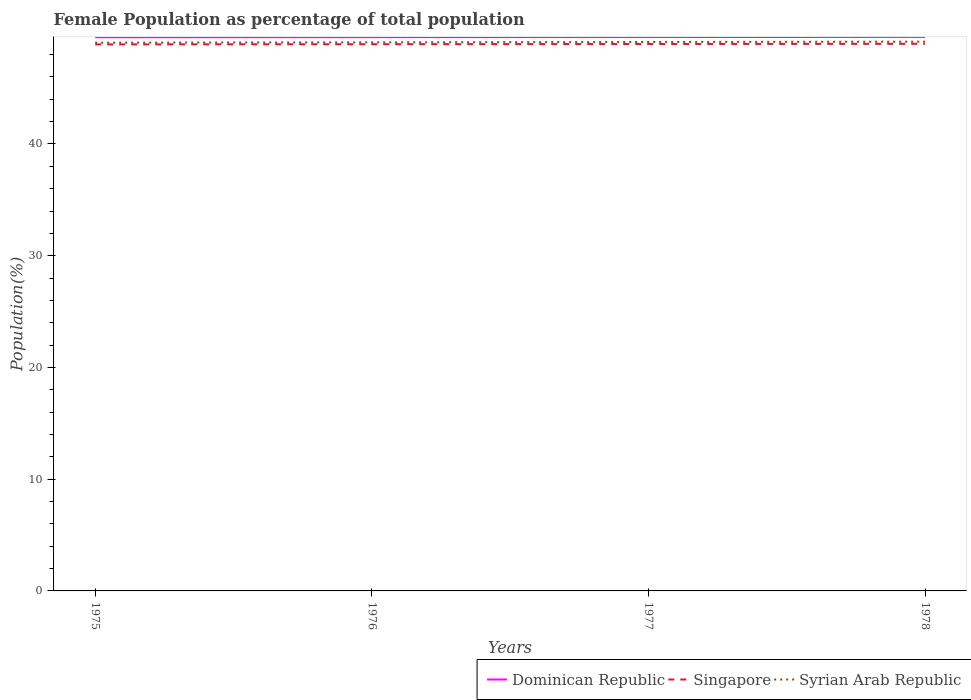Across all years, what is the maximum female population in in Singapore?
Provide a short and direct response. 48.91. In which year was the female population in in Syrian Arab Republic maximum?
Give a very brief answer. 1975. What is the total female population in in Syrian Arab Republic in the graph?
Provide a short and direct response. -0.03. What is the difference between the highest and the second highest female population in in Singapore?
Provide a succinct answer. 0.05. Is the female population in in Dominican Republic strictly greater than the female population in in Singapore over the years?
Make the answer very short. No. How many lines are there?
Your answer should be compact. 3. How many years are there in the graph?
Offer a terse response. 4. Are the values on the major ticks of Y-axis written in scientific E-notation?
Your answer should be very brief. No. What is the title of the graph?
Your answer should be compact. Female Population as percentage of total population. What is the label or title of the Y-axis?
Your answer should be compact. Population(%). What is the Population(%) in Dominican Republic in 1975?
Provide a succinct answer. 49.55. What is the Population(%) in Singapore in 1975?
Offer a very short reply. 48.91. What is the Population(%) in Syrian Arab Republic in 1975?
Offer a very short reply. 49.07. What is the Population(%) in Dominican Republic in 1976?
Ensure brevity in your answer.  49.56. What is the Population(%) of Singapore in 1976?
Offer a very short reply. 48.93. What is the Population(%) of Syrian Arab Republic in 1976?
Offer a very short reply. 49.1. What is the Population(%) of Dominican Republic in 1977?
Offer a terse response. 49.57. What is the Population(%) of Singapore in 1977?
Offer a very short reply. 48.95. What is the Population(%) in Syrian Arab Republic in 1977?
Provide a short and direct response. 49.13. What is the Population(%) of Dominican Republic in 1978?
Keep it short and to the point. 49.58. What is the Population(%) of Singapore in 1978?
Provide a short and direct response. 48.97. What is the Population(%) in Syrian Arab Republic in 1978?
Offer a terse response. 49.16. Across all years, what is the maximum Population(%) of Dominican Republic?
Keep it short and to the point. 49.58. Across all years, what is the maximum Population(%) of Singapore?
Your answer should be very brief. 48.97. Across all years, what is the maximum Population(%) of Syrian Arab Republic?
Your answer should be very brief. 49.16. Across all years, what is the minimum Population(%) of Dominican Republic?
Your answer should be very brief. 49.55. Across all years, what is the minimum Population(%) of Singapore?
Your answer should be very brief. 48.91. Across all years, what is the minimum Population(%) of Syrian Arab Republic?
Ensure brevity in your answer.  49.07. What is the total Population(%) in Dominican Republic in the graph?
Provide a succinct answer. 198.27. What is the total Population(%) of Singapore in the graph?
Your answer should be very brief. 195.76. What is the total Population(%) of Syrian Arab Republic in the graph?
Your answer should be very brief. 196.45. What is the difference between the Population(%) of Dominican Republic in 1975 and that in 1976?
Offer a terse response. -0.01. What is the difference between the Population(%) in Singapore in 1975 and that in 1976?
Give a very brief answer. -0.02. What is the difference between the Population(%) of Syrian Arab Republic in 1975 and that in 1976?
Ensure brevity in your answer.  -0.03. What is the difference between the Population(%) in Dominican Republic in 1975 and that in 1977?
Offer a very short reply. -0.02. What is the difference between the Population(%) of Singapore in 1975 and that in 1977?
Your answer should be compact. -0.04. What is the difference between the Population(%) in Syrian Arab Republic in 1975 and that in 1977?
Ensure brevity in your answer.  -0.06. What is the difference between the Population(%) in Dominican Republic in 1975 and that in 1978?
Offer a terse response. -0.03. What is the difference between the Population(%) in Singapore in 1975 and that in 1978?
Ensure brevity in your answer.  -0.05. What is the difference between the Population(%) of Syrian Arab Republic in 1975 and that in 1978?
Your response must be concise. -0.09. What is the difference between the Population(%) of Dominican Republic in 1976 and that in 1977?
Your answer should be very brief. -0.01. What is the difference between the Population(%) of Singapore in 1976 and that in 1977?
Provide a succinct answer. -0.02. What is the difference between the Population(%) in Syrian Arab Republic in 1976 and that in 1977?
Give a very brief answer. -0.03. What is the difference between the Population(%) in Dominican Republic in 1976 and that in 1978?
Your answer should be very brief. -0.02. What is the difference between the Population(%) in Singapore in 1976 and that in 1978?
Give a very brief answer. -0.04. What is the difference between the Population(%) of Syrian Arab Republic in 1976 and that in 1978?
Provide a short and direct response. -0.06. What is the difference between the Population(%) of Dominican Republic in 1977 and that in 1978?
Your answer should be compact. -0.01. What is the difference between the Population(%) of Singapore in 1977 and that in 1978?
Your answer should be very brief. -0.02. What is the difference between the Population(%) in Syrian Arab Republic in 1977 and that in 1978?
Ensure brevity in your answer.  -0.03. What is the difference between the Population(%) in Dominican Republic in 1975 and the Population(%) in Singapore in 1976?
Provide a succinct answer. 0.62. What is the difference between the Population(%) in Dominican Republic in 1975 and the Population(%) in Syrian Arab Republic in 1976?
Ensure brevity in your answer.  0.46. What is the difference between the Population(%) of Singapore in 1975 and the Population(%) of Syrian Arab Republic in 1976?
Ensure brevity in your answer.  -0.18. What is the difference between the Population(%) in Dominican Republic in 1975 and the Population(%) in Singapore in 1977?
Make the answer very short. 0.6. What is the difference between the Population(%) of Dominican Republic in 1975 and the Population(%) of Syrian Arab Republic in 1977?
Offer a very short reply. 0.42. What is the difference between the Population(%) of Singapore in 1975 and the Population(%) of Syrian Arab Republic in 1977?
Offer a terse response. -0.22. What is the difference between the Population(%) in Dominican Republic in 1975 and the Population(%) in Singapore in 1978?
Ensure brevity in your answer.  0.59. What is the difference between the Population(%) in Dominican Republic in 1975 and the Population(%) in Syrian Arab Republic in 1978?
Provide a short and direct response. 0.39. What is the difference between the Population(%) in Singapore in 1975 and the Population(%) in Syrian Arab Republic in 1978?
Make the answer very short. -0.25. What is the difference between the Population(%) of Dominican Republic in 1976 and the Population(%) of Singapore in 1977?
Offer a very short reply. 0.61. What is the difference between the Population(%) of Dominican Republic in 1976 and the Population(%) of Syrian Arab Republic in 1977?
Your answer should be compact. 0.43. What is the difference between the Population(%) in Singapore in 1976 and the Population(%) in Syrian Arab Republic in 1977?
Your answer should be very brief. -0.2. What is the difference between the Population(%) of Dominican Republic in 1976 and the Population(%) of Singapore in 1978?
Your answer should be compact. 0.6. What is the difference between the Population(%) in Dominican Republic in 1976 and the Population(%) in Syrian Arab Republic in 1978?
Provide a succinct answer. 0.4. What is the difference between the Population(%) in Singapore in 1976 and the Population(%) in Syrian Arab Republic in 1978?
Offer a terse response. -0.23. What is the difference between the Population(%) of Dominican Republic in 1977 and the Population(%) of Singapore in 1978?
Provide a succinct answer. 0.6. What is the difference between the Population(%) in Dominican Republic in 1977 and the Population(%) in Syrian Arab Republic in 1978?
Offer a very short reply. 0.41. What is the difference between the Population(%) in Singapore in 1977 and the Population(%) in Syrian Arab Republic in 1978?
Give a very brief answer. -0.21. What is the average Population(%) of Dominican Republic per year?
Provide a succinct answer. 49.57. What is the average Population(%) in Singapore per year?
Your answer should be very brief. 48.94. What is the average Population(%) in Syrian Arab Republic per year?
Ensure brevity in your answer.  49.11. In the year 1975, what is the difference between the Population(%) of Dominican Republic and Population(%) of Singapore?
Your answer should be very brief. 0.64. In the year 1975, what is the difference between the Population(%) of Dominican Republic and Population(%) of Syrian Arab Republic?
Offer a very short reply. 0.49. In the year 1975, what is the difference between the Population(%) of Singapore and Population(%) of Syrian Arab Republic?
Provide a short and direct response. -0.15. In the year 1976, what is the difference between the Population(%) in Dominican Republic and Population(%) in Singapore?
Offer a very short reply. 0.63. In the year 1976, what is the difference between the Population(%) in Dominican Republic and Population(%) in Syrian Arab Republic?
Provide a short and direct response. 0.47. In the year 1976, what is the difference between the Population(%) in Singapore and Population(%) in Syrian Arab Republic?
Give a very brief answer. -0.17. In the year 1977, what is the difference between the Population(%) in Dominican Republic and Population(%) in Singapore?
Ensure brevity in your answer.  0.62. In the year 1977, what is the difference between the Population(%) of Dominican Republic and Population(%) of Syrian Arab Republic?
Your answer should be very brief. 0.44. In the year 1977, what is the difference between the Population(%) of Singapore and Population(%) of Syrian Arab Republic?
Your answer should be compact. -0.18. In the year 1978, what is the difference between the Population(%) of Dominican Republic and Population(%) of Singapore?
Your response must be concise. 0.61. In the year 1978, what is the difference between the Population(%) of Dominican Republic and Population(%) of Syrian Arab Republic?
Your response must be concise. 0.42. In the year 1978, what is the difference between the Population(%) in Singapore and Population(%) in Syrian Arab Republic?
Your answer should be very brief. -0.19. What is the ratio of the Population(%) of Syrian Arab Republic in 1975 to that in 1976?
Keep it short and to the point. 1. What is the ratio of the Population(%) in Singapore in 1975 to that in 1977?
Your answer should be very brief. 1. What is the ratio of the Population(%) of Syrian Arab Republic in 1975 to that in 1978?
Keep it short and to the point. 1. What is the ratio of the Population(%) of Syrian Arab Republic in 1976 to that in 1977?
Your response must be concise. 1. What is the ratio of the Population(%) of Dominican Republic in 1976 to that in 1978?
Ensure brevity in your answer.  1. What is the ratio of the Population(%) of Syrian Arab Republic in 1976 to that in 1978?
Your answer should be very brief. 1. What is the ratio of the Population(%) of Syrian Arab Republic in 1977 to that in 1978?
Offer a very short reply. 1. What is the difference between the highest and the second highest Population(%) in Dominican Republic?
Ensure brevity in your answer.  0.01. What is the difference between the highest and the second highest Population(%) of Singapore?
Make the answer very short. 0.02. What is the difference between the highest and the second highest Population(%) in Syrian Arab Republic?
Provide a succinct answer. 0.03. What is the difference between the highest and the lowest Population(%) of Dominican Republic?
Make the answer very short. 0.03. What is the difference between the highest and the lowest Population(%) in Singapore?
Give a very brief answer. 0.05. What is the difference between the highest and the lowest Population(%) in Syrian Arab Republic?
Your answer should be compact. 0.09. 